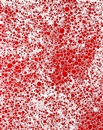What is this photo about? The image showcases a vivid example of pointillism, an art technique where small, distinct dots of color are applied to form an image. Here, the predominance of red and white dots creates a visual impact that suggests depth and texture, resembling a dynamic burst of energy or a celestial phenomenon. The abstract nature of the piece leaves much to interpretation, possibly igniting thoughts of cosmic events or vibrant natural elements like fire or flowers, depending on the viewer's imagination. 